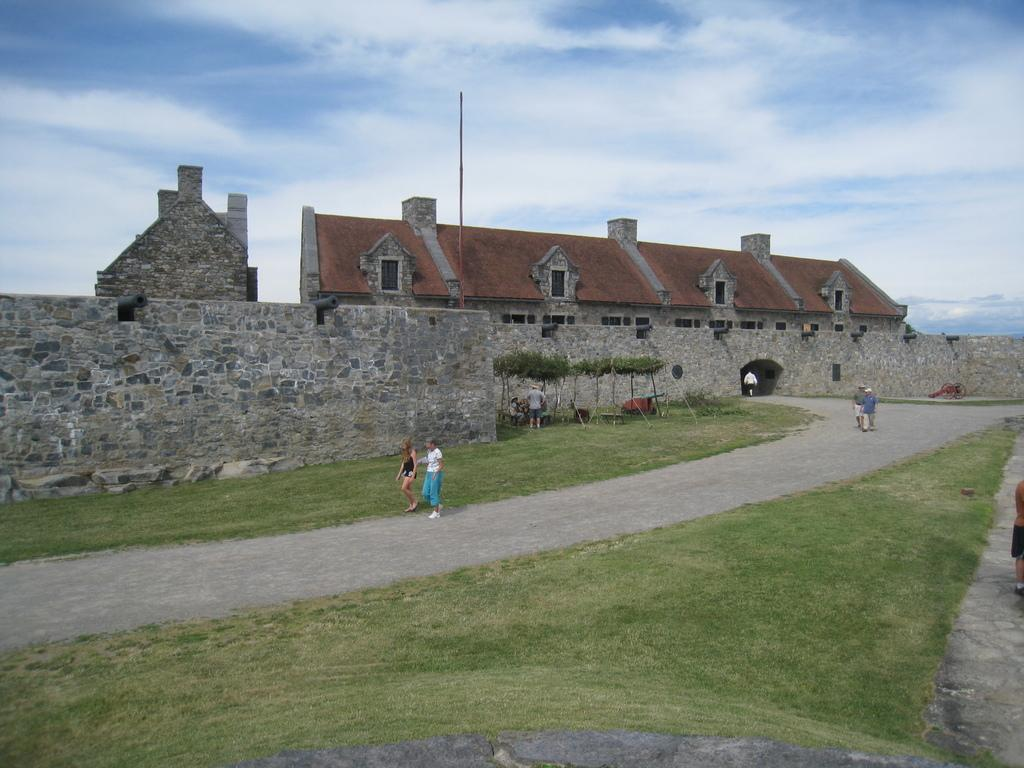What type of structures can be seen in the image? There are buildings in the image. What feature is visible on the buildings? There are windows visible in the image. What type of barrier is present in the image? There is a wall in the image. What type of vegetation is present in the image? There are trees in the image. Who or what is present in the image? There are people in the image. What colors are used to depict the sky in the image? The sky is in white and blue color in the image. What type of distribution system is present in the image? There is no distribution system mentioned or visible in the image. Who or what is the representative of the people in the image? There is no specific representative mentioned or visible in the image. 